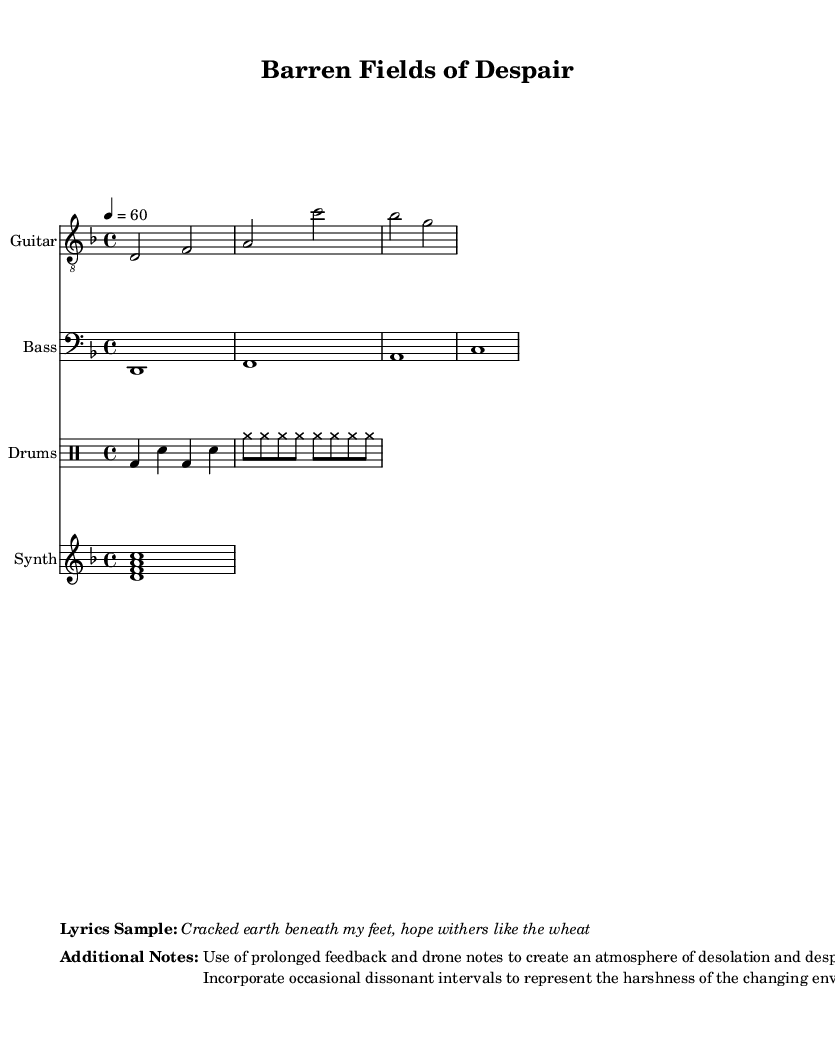What is the key signature of this music? The key signature is indicated at the beginning of the score. In this case, it is D minor, which has one flat (B flat).
Answer: D minor What is the time signature of this music? The time signature is displayed at the start of the score and it reads 4/4, meaning there are four beats in each measure.
Answer: 4/4 What is the tempo marking for this piece? The tempo marking is noted in the score with ‘4 = 60’, indicating the quarter note gets 60 beats per minute.
Answer: 60 How many measures does the guitar riff contain? By counting the sequence of notes in the guitar riff, there are a total of four measures present in the music.
Answer: 4 What is the instrument used for the bass line? The score specifically indicates the instrument name in the staff, which is “Bass” for the bass line.
Answer: Bass What technique is emphasized to create an atmosphere of desolation? The additional notes describe the use of prolonged feedback and drone notes, which contribute to the overall atmosphere of desolation.
Answer: Prolonged feedback and drone notes What is one specific emotional element represented in the lyrics? The lyrics describe the feeling of hopelessness as expressed in the lines, with the specific phrase "hope withers like the wheat."
Answer: Hopelessness 